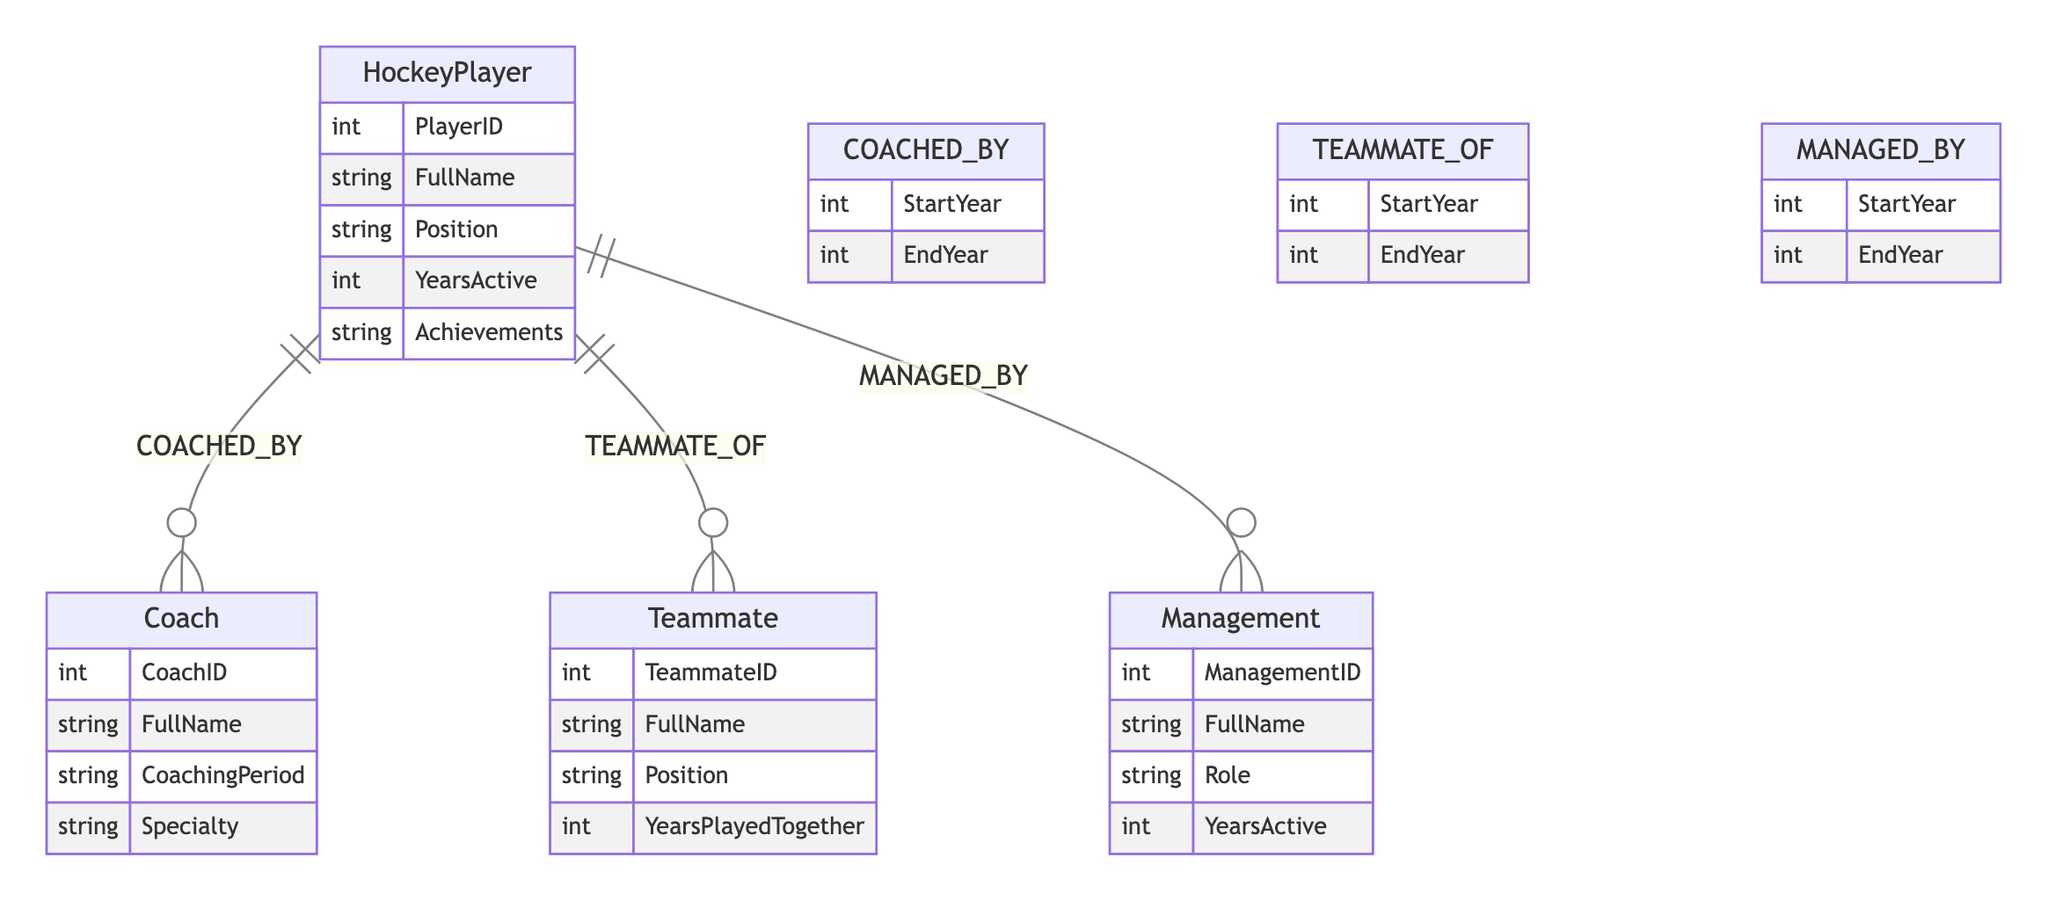What is the primary role of the HockeyPlayer in the diagram? The HockeyPlayer serves as the central entity connecting the relationships with Coaches, Teammates, and Management. The diagram illustrates how the HockeyPlayer interacts with these other roles via specific relationships.
Answer: HockeyPlayer How many main entities are present in the diagram? The diagram represents four main entities: HockeyPlayer, Coach, Teammate, and Management. Each of these entities plays a specific role within the context of a hockey player's career.
Answer: Four What relationship connects the HockeyPlayer and Coach entities? The connection between the HockeyPlayer and Coach is defined by the relationship labeled "COACHED_BY," indicating the coaching relationship across specific years.
Answer: COACHED_BY What attribute of the Teammate entity indicates the duration of their collaboration with the HockeyPlayer? The attribute "YearsPlayedTogether" provides insight into how long the Teammate has played alongside the HockeyPlayer, detailing their collaborative period.
Answer: YearsPlayedTogether In what years is the HockeyPlayer represented as being coached? The relationship "COACHED_BY" includes "StartYear" and "EndYear" attributes that specify the time frame during which the HockeyPlayer was coached, although the actual years are not provided in the data sample.
Answer: StartYear, EndYear From which entity does the Management derive its role related to the HockeyPlayer? The Management entity relates to the HockeyPlayer through the "MANAGED_BY" relationship, which indicates the role of management within the player's context.
Answer: MANAGED_BY Which attribute under the Coach entity can specify their area of expertise? The attribute "Specialty" under the Coach entity denotes the area in which a coach specializes, clarifying their focus within the coaching framework.
Answer: Specialty What connection exists between the HockeyPlayer and Management entities? The “MANAGED_BY” relationship defines the connection between the HockeyPlayer and Management, indicating the management oversight over the player in specific periods.
Answer: MANAGED_BY Which two types of relationships share the same attributes in terms of start and end years? The "COACHED_BY" and "MANAGED_BY" relationships both include the attributes "StartYear" and "EndYear," allowing for time-based analysis of coaching and management.
Answer: COACHED_BY, MANAGED_BY 